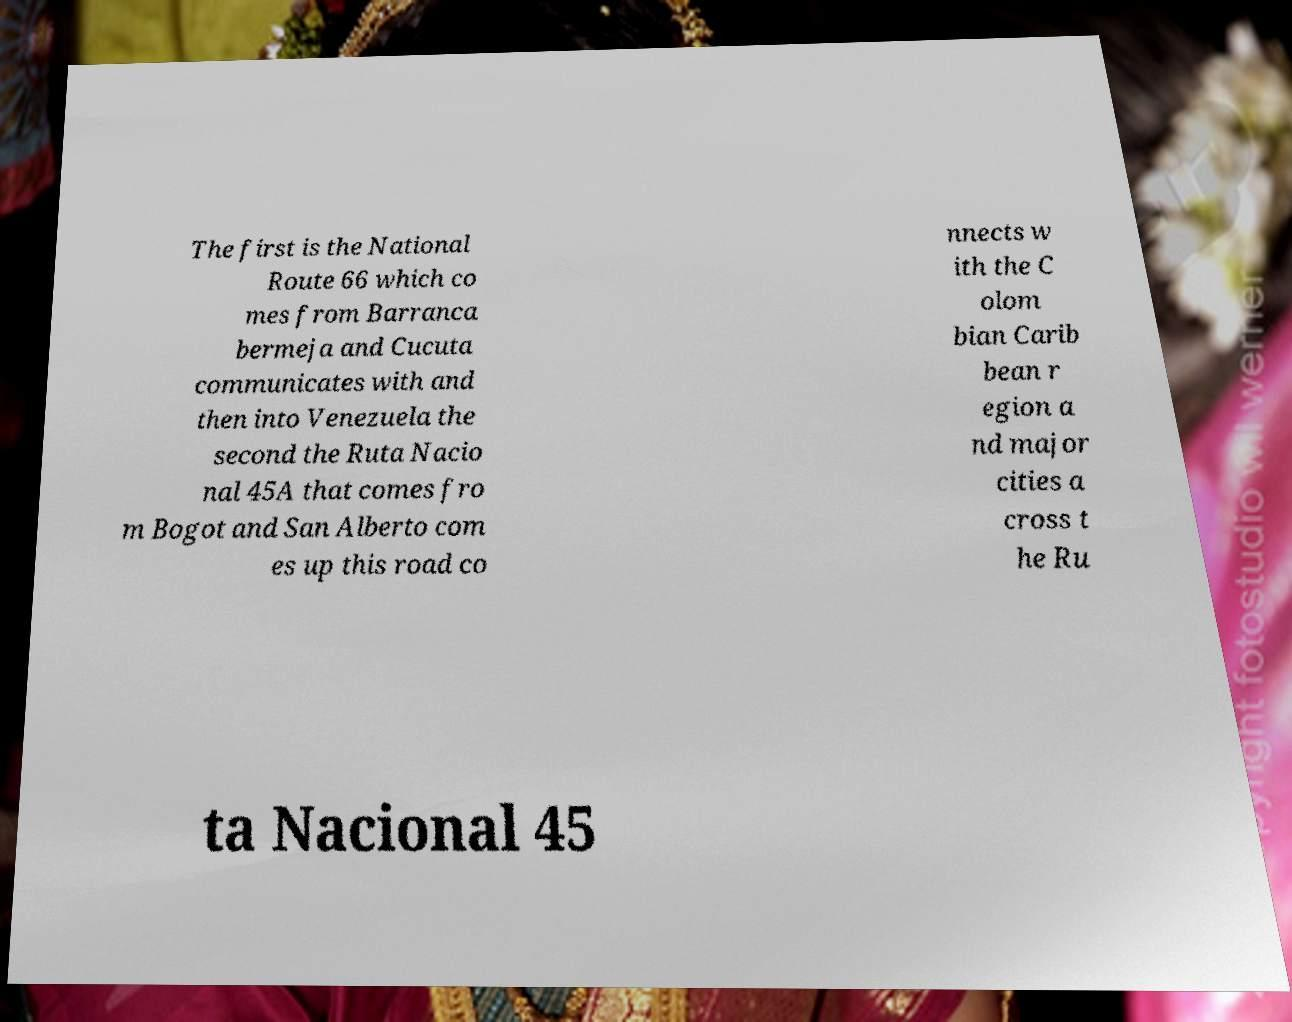Can you read and provide the text displayed in the image?This photo seems to have some interesting text. Can you extract and type it out for me? The first is the National Route 66 which co mes from Barranca bermeja and Cucuta communicates with and then into Venezuela the second the Ruta Nacio nal 45A that comes fro m Bogot and San Alberto com es up this road co nnects w ith the C olom bian Carib bean r egion a nd major cities a cross t he Ru ta Nacional 45 